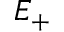<formula> <loc_0><loc_0><loc_500><loc_500>E _ { + }</formula> 